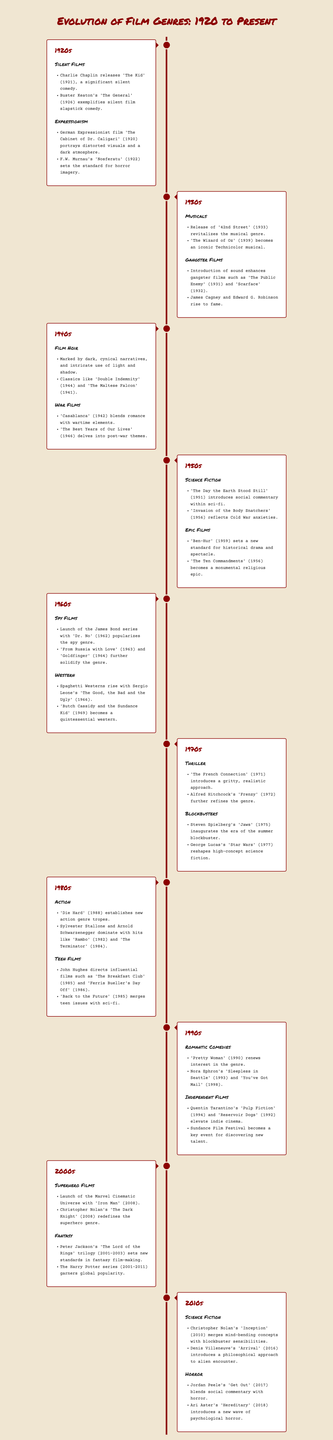What significant silent comedy was released by Charlie Chaplin in 1921? The document mentions 'The Kid' as the significant silent comedy released in 1921.
Answer: 'The Kid' Which genre is exemplified by Buster Keaton's 'The General'? The document categorizes 'The General' as a silent film slapstick comedy.
Answer: Silent Film Slapstick Comedy What year did the iconic Technicolor musical 'The Wizard of Oz' release? According to the document, 'The Wizard of Oz' was released in 1939, which is mentioned under the musical genre.
Answer: 1939 What innovative film introduced the superhero genre in 2008? The document states that 'Iron Man' launched the superhero genre in 2008.
Answer: 'Iron Man' Which genre do 'Casablanca' (1942) and 'The Best Years of Our Lives' (1946) represent? The timeline categorizes both 'Casablanca’ and 'The Best Years of Our Lives' as war films.
Answer: War Films How does 'The French Connection' (1971) characterize the thriller genre? The document describes 'The French Connection' as introducing a gritty, realistic approach within the thriller genre.
Answer: Gritty, Realistic Approach Which decade marked the rise of Spaghetti Westerns? The document indicates that Spaghetti Westerns rose in the 1960s, as highlighted by Sergio Leone's work.
Answer: 1960s What impact did 'Pulp Fiction' (1994) have on cinema? According to the document, 'Pulp Fiction' elevated indie cinema, indicating its importance in the 1990s.
Answer: Elevated Indie Cinema What combined genre does 'Get Out' (2017) represent? The document states that 'Get Out' blends social commentary with horror.
Answer: Horror What marked the beginning of the summer blockbuster era? The timeline attributes the beginning of the summer blockbuster era to 'Jaws' (1975).
Answer: 'Jaws' 